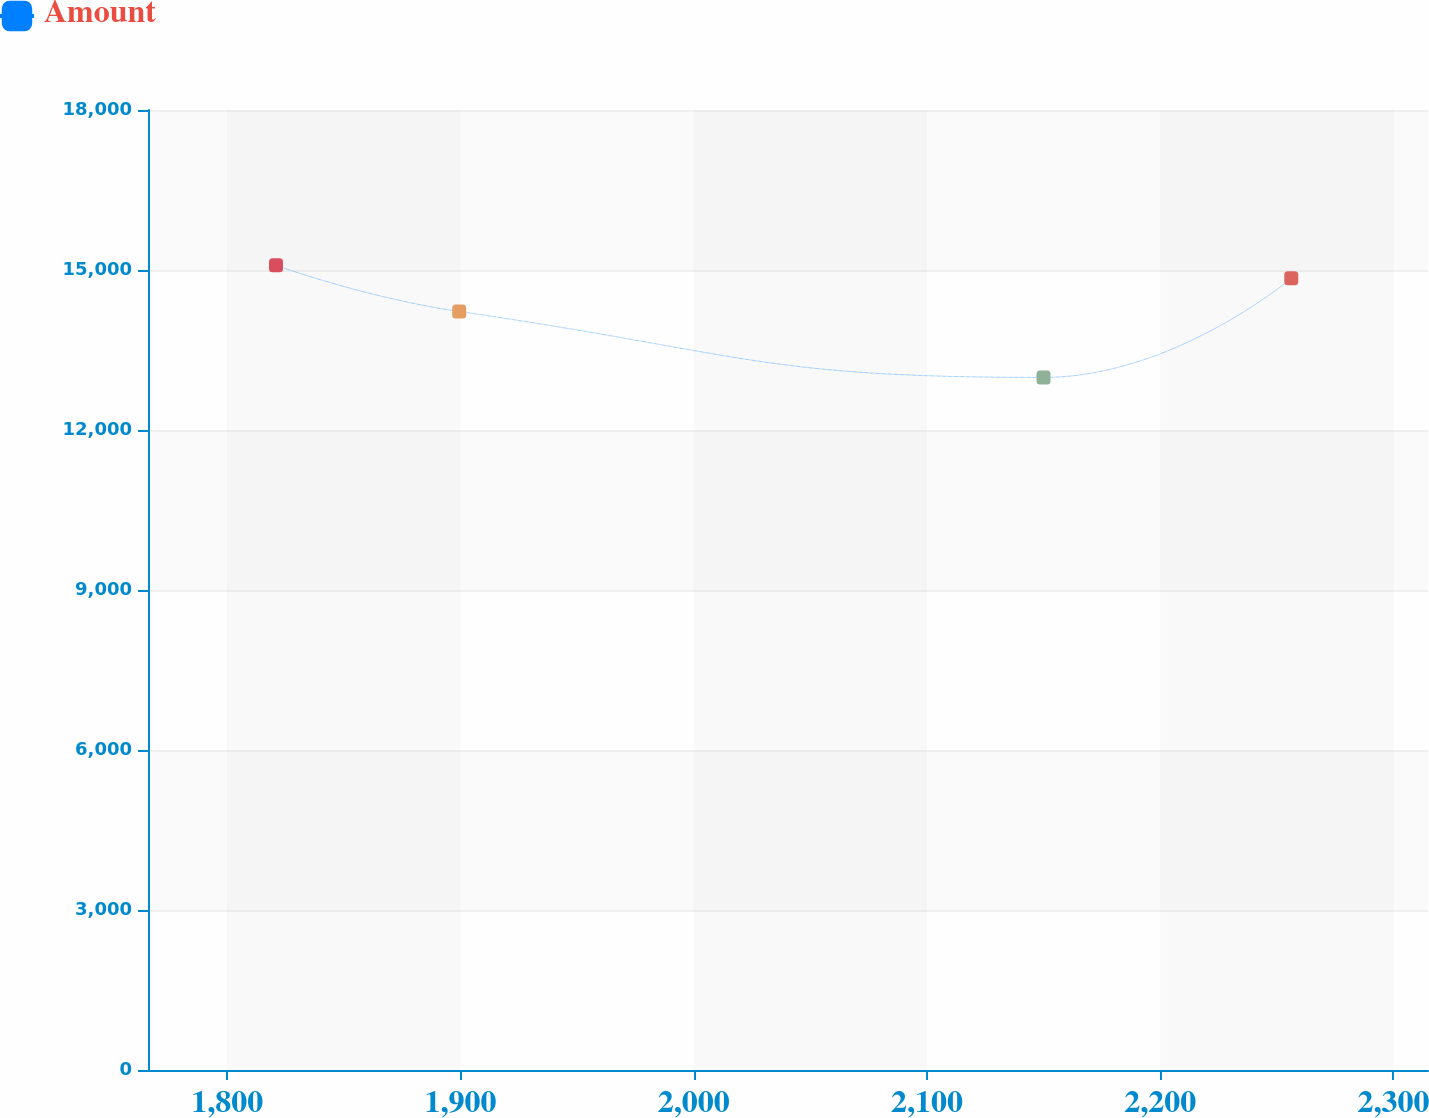Convert chart to OTSL. <chart><loc_0><loc_0><loc_500><loc_500><line_chart><ecel><fcel>Amount<nl><fcel>1820.94<fcel>15087.4<nl><fcel>1899.49<fcel>14222.6<nl><fcel>2149.99<fcel>12985.9<nl><fcel>2256.21<fcel>14844.1<nl><fcel>2369.69<fcel>12459.5<nl></chart> 